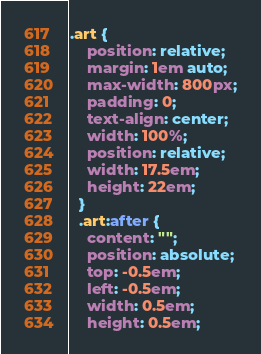Convert code to text. <code><loc_0><loc_0><loc_500><loc_500><_CSS_>.art {
    position: relative;
    margin: 1em auto;
    max-width: 800px;
    padding: 0;
    text-align: center;
    width: 100%;
    position: relative;
    width: 17.5em;
    height: 22em;
  }
  .art:after {
    content: "";
    position: absolute;
    top: -0.5em;
    left: -0.5em;
    width: 0.5em;
    height: 0.5em;</code> 